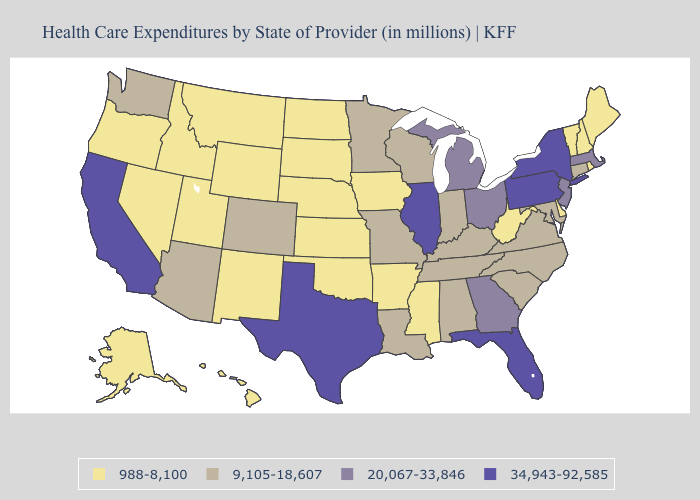What is the value of Mississippi?
Concise answer only. 988-8,100. Name the states that have a value in the range 9,105-18,607?
Be succinct. Alabama, Arizona, Colorado, Connecticut, Indiana, Kentucky, Louisiana, Maryland, Minnesota, Missouri, North Carolina, South Carolina, Tennessee, Virginia, Washington, Wisconsin. Among the states that border Kentucky , does Illinois have the highest value?
Be succinct. Yes. Name the states that have a value in the range 34,943-92,585?
Short answer required. California, Florida, Illinois, New York, Pennsylvania, Texas. What is the highest value in the Northeast ?
Short answer required. 34,943-92,585. What is the value of Arizona?
Keep it brief. 9,105-18,607. Does Vermont have the lowest value in the Northeast?
Write a very short answer. Yes. Does Tennessee have the lowest value in the South?
Quick response, please. No. Which states have the lowest value in the MidWest?
Quick response, please. Iowa, Kansas, Nebraska, North Dakota, South Dakota. Does Texas have the highest value in the USA?
Be succinct. Yes. What is the highest value in states that border New Jersey?
Short answer required. 34,943-92,585. Which states have the highest value in the USA?
Answer briefly. California, Florida, Illinois, New York, Pennsylvania, Texas. What is the value of Virginia?
Write a very short answer. 9,105-18,607. Does Georgia have a higher value than Michigan?
Keep it brief. No. Does Georgia have the lowest value in the USA?
Be succinct. No. 